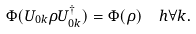<formula> <loc_0><loc_0><loc_500><loc_500>\Phi ( U _ { 0 k } \rho U _ { 0 k } ^ { \dagger } ) = \Phi ( \rho ) \ \ h \forall k .</formula> 